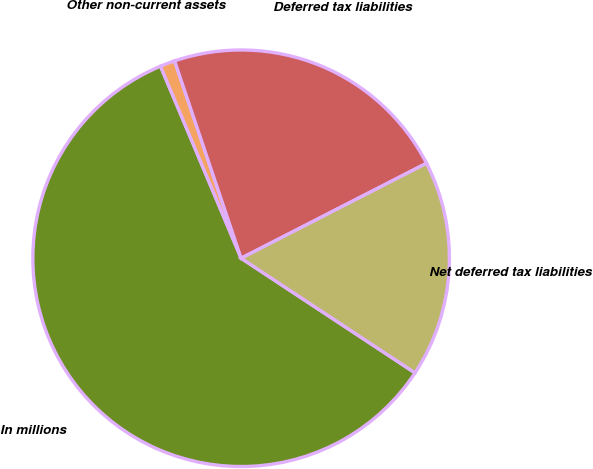Convert chart to OTSL. <chart><loc_0><loc_0><loc_500><loc_500><pie_chart><fcel>In millions<fcel>Other non-current assets<fcel>Deferred tax liabilities<fcel>Net deferred tax liabilities<nl><fcel>59.4%<fcel>1.15%<fcel>22.64%<fcel>16.81%<nl></chart> 